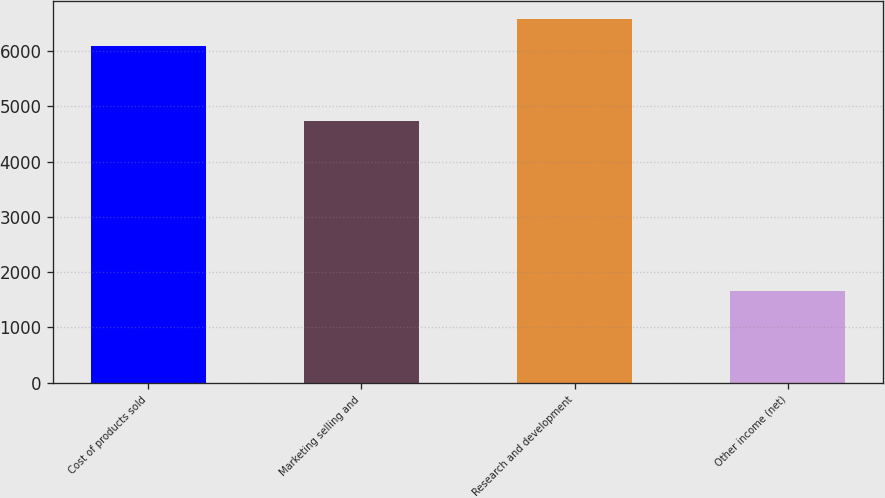Convert chart to OTSL. <chart><loc_0><loc_0><loc_500><loc_500><bar_chart><fcel>Cost of products sold<fcel>Marketing selling and<fcel>Research and development<fcel>Other income (net)<nl><fcel>6092<fcel>4733<fcel>6574<fcel>1654<nl></chart> 